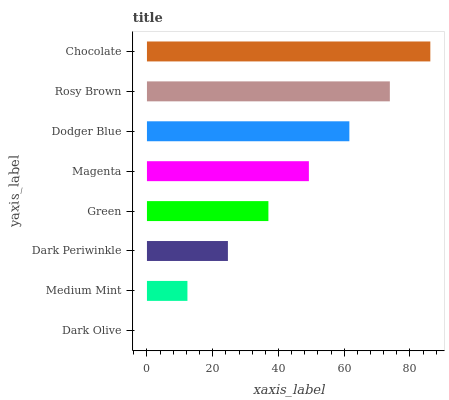Is Dark Olive the minimum?
Answer yes or no. Yes. Is Chocolate the maximum?
Answer yes or no. Yes. Is Medium Mint the minimum?
Answer yes or no. No. Is Medium Mint the maximum?
Answer yes or no. No. Is Medium Mint greater than Dark Olive?
Answer yes or no. Yes. Is Dark Olive less than Medium Mint?
Answer yes or no. Yes. Is Dark Olive greater than Medium Mint?
Answer yes or no. No. Is Medium Mint less than Dark Olive?
Answer yes or no. No. Is Magenta the high median?
Answer yes or no. Yes. Is Green the low median?
Answer yes or no. Yes. Is Rosy Brown the high median?
Answer yes or no. No. Is Medium Mint the low median?
Answer yes or no. No. 